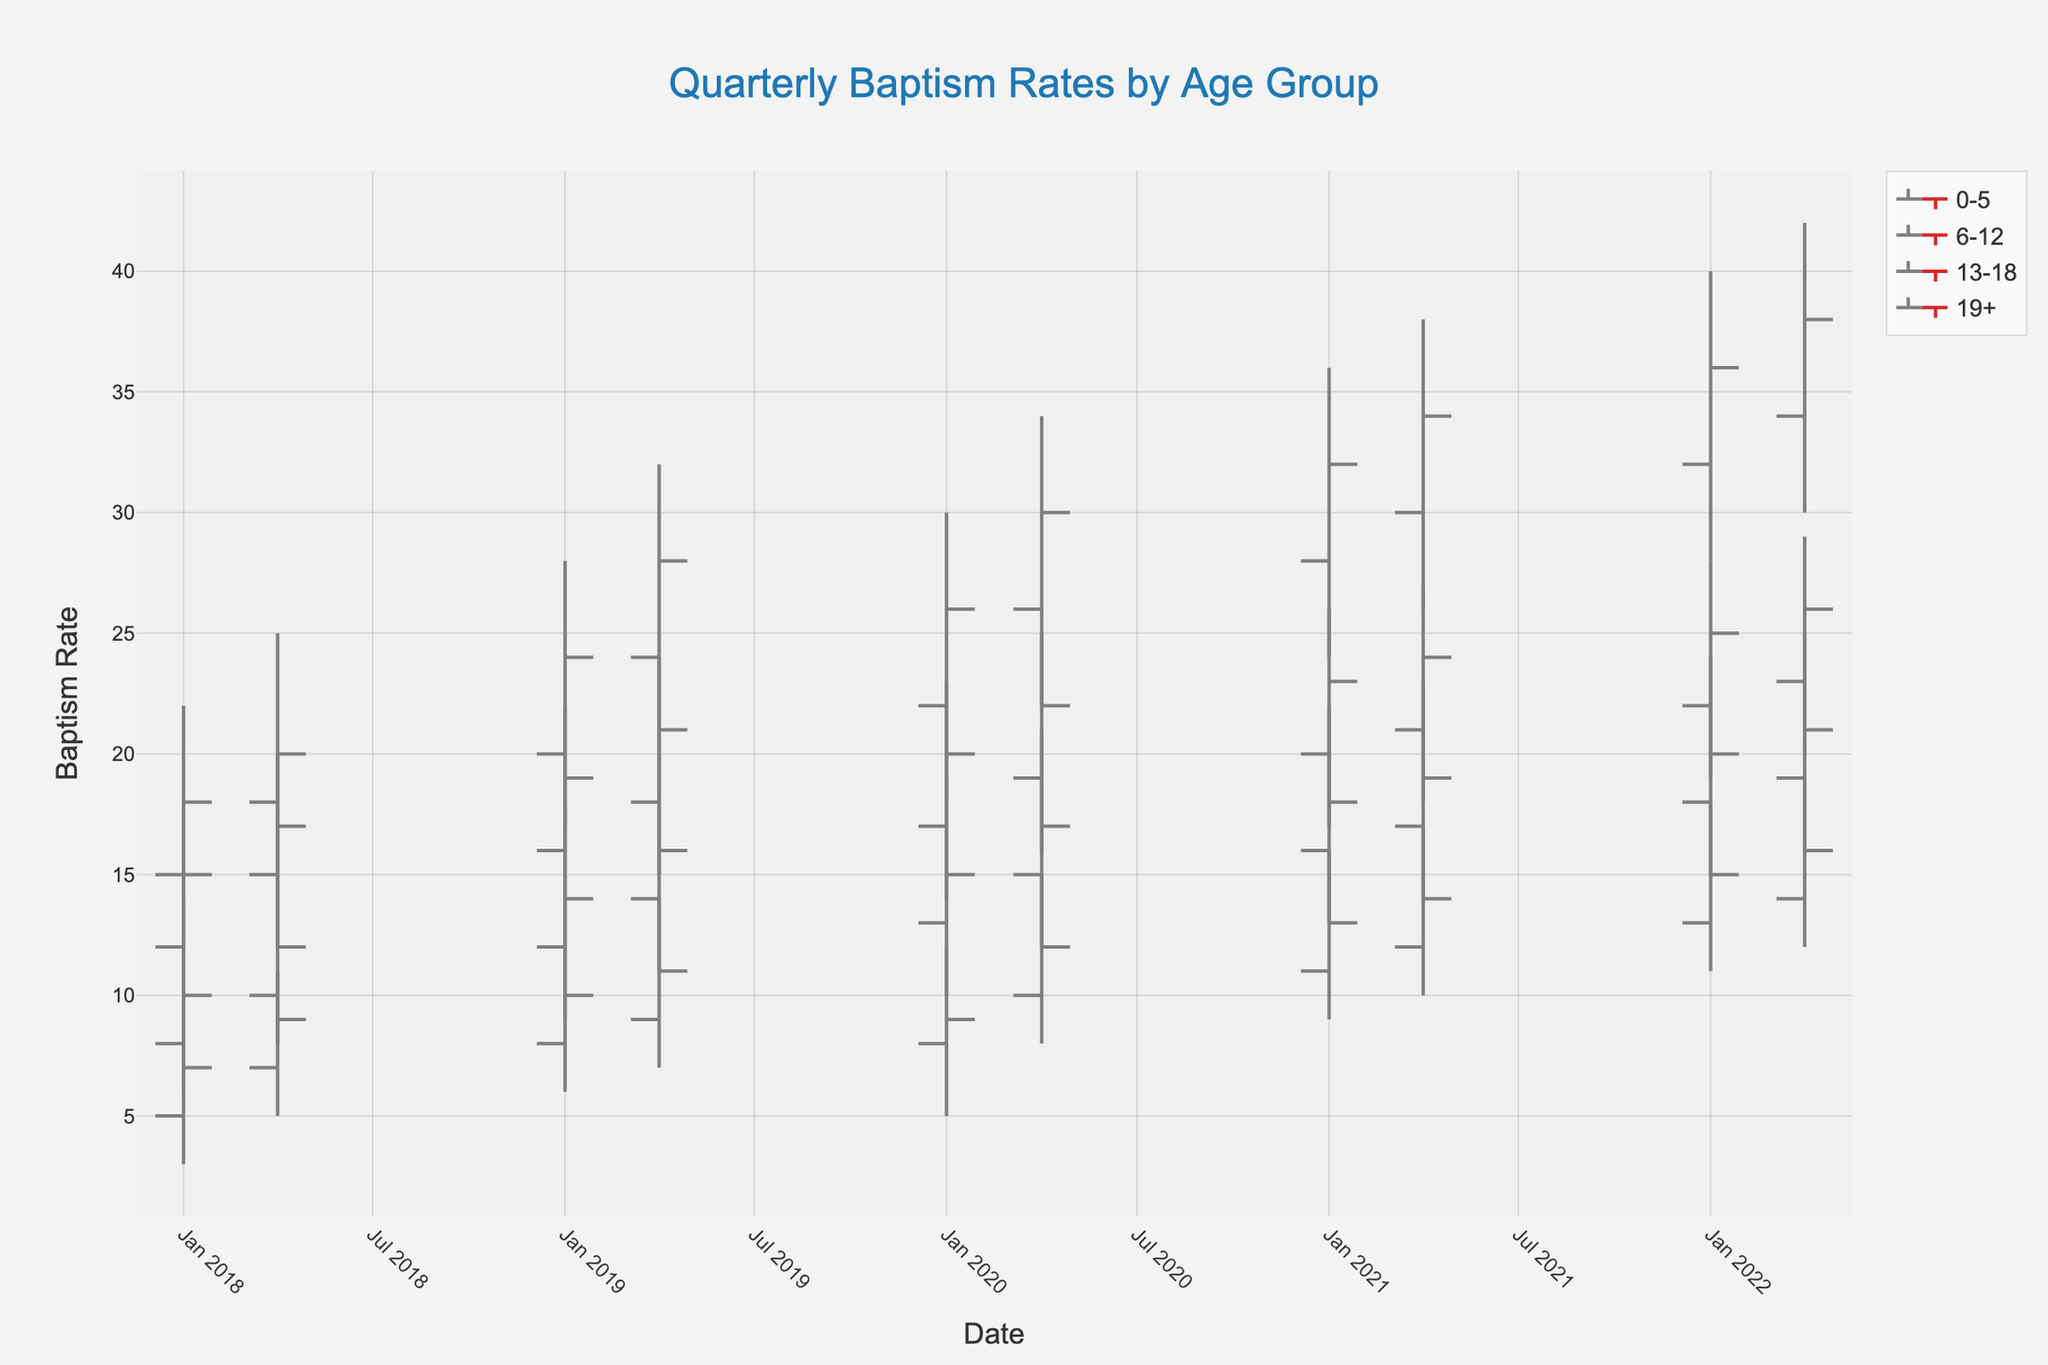What is the title of the figure? The title of the figure is usually displayed prominently at the top. In this case, it reads "Quarterly Baptism Rates by Age Group".
Answer: Quarterly Baptism Rates by Age Group What are the age groups shown in the figure? The age groups can be seen by examining the labels associated with different traces on the plot. They are 0-5, 6-12, 13-18, and 19+.
Answer: 0-5, 6-12, 13-18, 19+ Which age group had the highest Closing baptism rate in 2020-Q2? The highest closing rates in 2020-Q2 can be identified by looking at the maximum value among the closing rates for 0-5, 6-12, 13-18, and 19+ age groups. For 2020-Q2, the 0-5 group had a closing rate of 30, which is the highest.
Answer: 0-5 During which year and quarter did the 6-12 age group experience its highest High value? By scanning the High values for the 6-12 age group across all periods, it is seen that the highest High value for this group is 25 seen in 2022-Q2.
Answer: 2022-Q2 What general trend can be observed in the baptism rates of the 0-5 age group over the years? Examining the Open, High, Low, and Close values for the 0-5 age group over the periods reveals an increase in baptism rates. This is indicated by the generally increasing values over time.
Answer: Increasing trend What is the difference between the highest and lowest values (High-Low) for the 13-18 age group in 2019-Q2? To find the difference, subtract the Low value from the High value for the 13-18 age group in 2019-Q2: 14 - 7 = 7.
Answer: 7 Which quarter in 2021 had the highest overall baptism rate? To find this, compare the High values of each age group for 2021-Q1 and 2021-Q2. The highest values are 38 for 0-5, 23 for 6-12, 17 for 13-18, and 27 for 19+ in 2021-Q2. The highest value of 38 is in 2021-Q2 for the age group 0-5, making it the highest overall.
Answer: 2021-Q2 How do the opening rates for the 19+ age group in 2018-Q1 compare to those in 2022-Q2? The opening rate in 2018-Q1 for the 19+ group is 12, while in 2022-Q2 it is 23. By comparing the values, it is clear that the opening rate in 2022-Q2 is higher.
Answer: Higher in 2022-Q2 